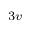<formula> <loc_0><loc_0><loc_500><loc_500>_ { 3 v }</formula> 